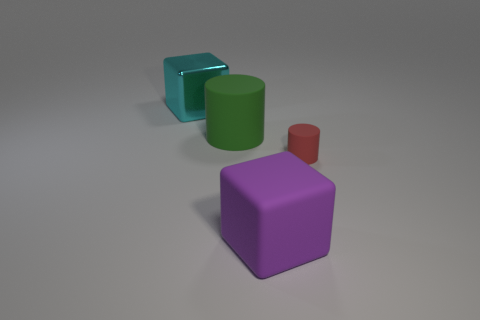Is there anything else that is the same size as the red matte object?
Your response must be concise. No. What color is the large block that is behind the big matte thing that is behind the red matte object?
Your response must be concise. Cyan. What is the size of the rubber thing on the right side of the large block right of the big cyan metallic cube?
Keep it short and to the point. Small. What number of other things are the same size as the red cylinder?
Provide a short and direct response. 0. What color is the small object right of the large rubber thing behind the cube in front of the tiny red matte cylinder?
Provide a short and direct response. Red. How many other objects are the same shape as the large cyan object?
Ensure brevity in your answer.  1. The big thing that is left of the big cylinder has what shape?
Ensure brevity in your answer.  Cube. There is a block that is in front of the large cyan object; are there any green cylinders that are in front of it?
Make the answer very short. No. What color is the object that is in front of the large green cylinder and to the left of the small cylinder?
Provide a succinct answer. Purple. There is a rubber cylinder that is left of the large cube that is right of the big cyan object; is there a big cyan shiny object that is right of it?
Offer a very short reply. No. 